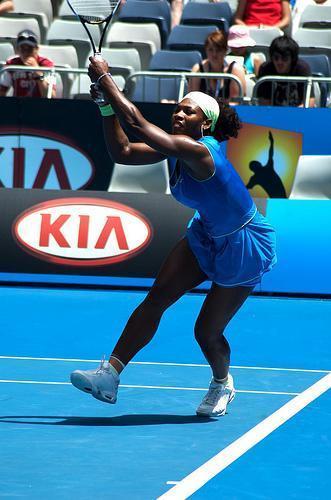How many people are shown in the front row?
Give a very brief answer. 3. 